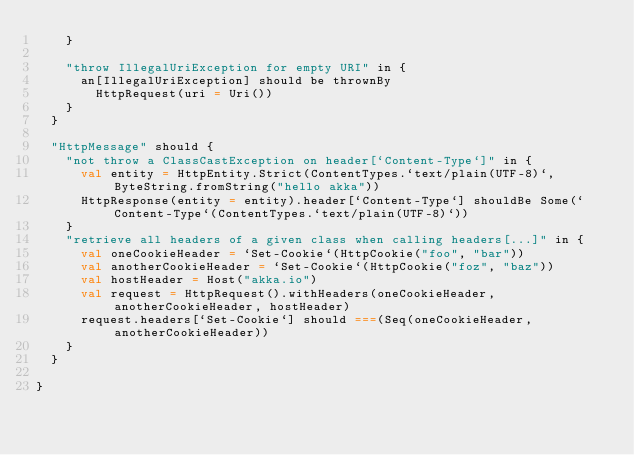<code> <loc_0><loc_0><loc_500><loc_500><_Scala_>    }

    "throw IllegalUriException for empty URI" in {
      an[IllegalUriException] should be thrownBy
        HttpRequest(uri = Uri())
    }
  }

  "HttpMessage" should {
    "not throw a ClassCastException on header[`Content-Type`]" in {
      val entity = HttpEntity.Strict(ContentTypes.`text/plain(UTF-8)`, ByteString.fromString("hello akka"))
      HttpResponse(entity = entity).header[`Content-Type`] shouldBe Some(`Content-Type`(ContentTypes.`text/plain(UTF-8)`))
    }
    "retrieve all headers of a given class when calling headers[...]" in {
      val oneCookieHeader = `Set-Cookie`(HttpCookie("foo", "bar"))
      val anotherCookieHeader = `Set-Cookie`(HttpCookie("foz", "baz"))
      val hostHeader = Host("akka.io")
      val request = HttpRequest().withHeaders(oneCookieHeader, anotherCookieHeader, hostHeader)
      request.headers[`Set-Cookie`] should ===(Seq(oneCookieHeader, anotherCookieHeader))
    }
  }

}
</code> 